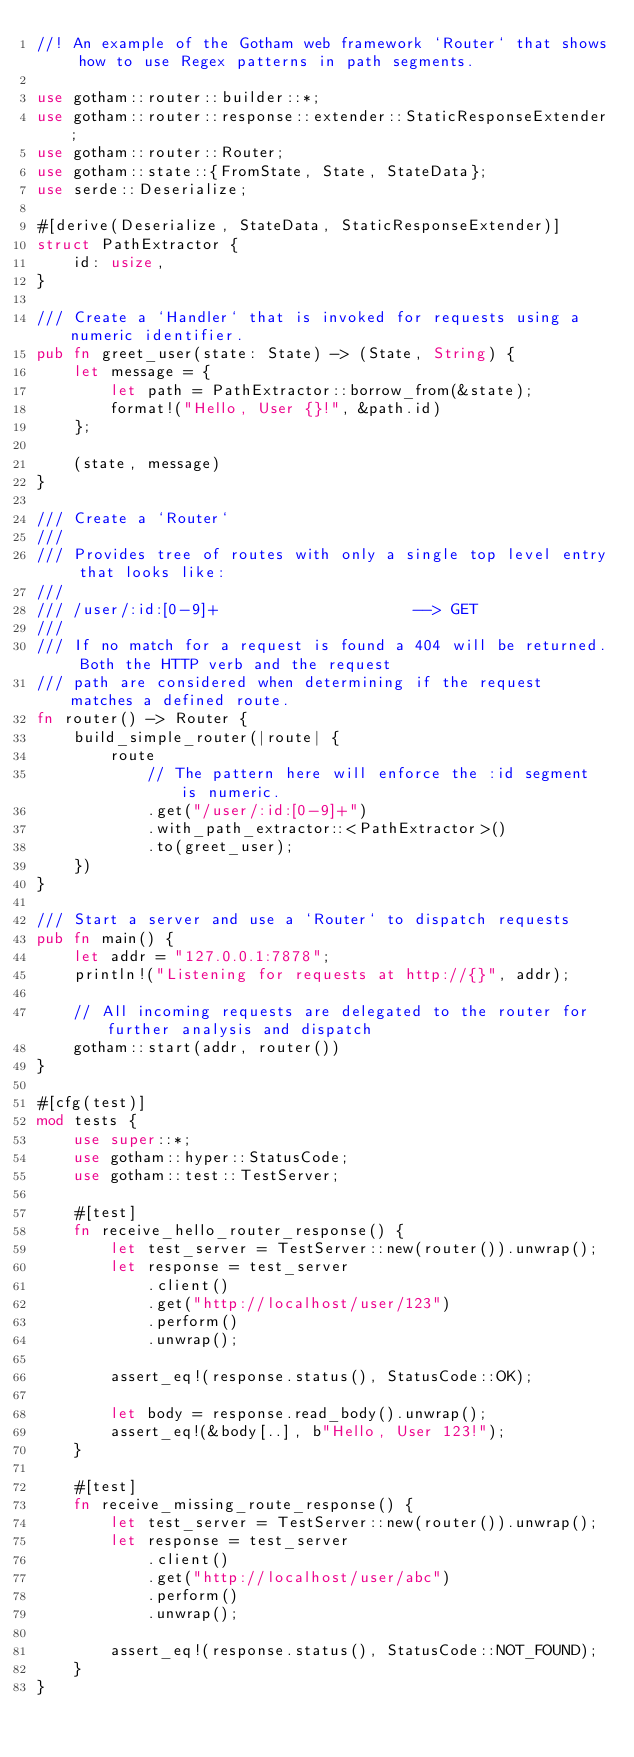<code> <loc_0><loc_0><loc_500><loc_500><_Rust_>//! An example of the Gotham web framework `Router` that shows how to use Regex patterns in path segments.

use gotham::router::builder::*;
use gotham::router::response::extender::StaticResponseExtender;
use gotham::router::Router;
use gotham::state::{FromState, State, StateData};
use serde::Deserialize;

#[derive(Deserialize, StateData, StaticResponseExtender)]
struct PathExtractor {
    id: usize,
}

/// Create a `Handler` that is invoked for requests using a numeric identifier.
pub fn greet_user(state: State) -> (State, String) {
    let message = {
        let path = PathExtractor::borrow_from(&state);
        format!("Hello, User {}!", &path.id)
    };

    (state, message)
}

/// Create a `Router`
///
/// Provides tree of routes with only a single top level entry that looks like:
///
/// /user/:id:[0-9]+                     --> GET
///
/// If no match for a request is found a 404 will be returned. Both the HTTP verb and the request
/// path are considered when determining if the request matches a defined route.
fn router() -> Router {
    build_simple_router(|route| {
        route
            // The pattern here will enforce the :id segment is numeric.
            .get("/user/:id:[0-9]+")
            .with_path_extractor::<PathExtractor>()
            .to(greet_user);
    })
}

/// Start a server and use a `Router` to dispatch requests
pub fn main() {
    let addr = "127.0.0.1:7878";
    println!("Listening for requests at http://{}", addr);

    // All incoming requests are delegated to the router for further analysis and dispatch
    gotham::start(addr, router())
}

#[cfg(test)]
mod tests {
    use super::*;
    use gotham::hyper::StatusCode;
    use gotham::test::TestServer;

    #[test]
    fn receive_hello_router_response() {
        let test_server = TestServer::new(router()).unwrap();
        let response = test_server
            .client()
            .get("http://localhost/user/123")
            .perform()
            .unwrap();

        assert_eq!(response.status(), StatusCode::OK);

        let body = response.read_body().unwrap();
        assert_eq!(&body[..], b"Hello, User 123!");
    }

    #[test]
    fn receive_missing_route_response() {
        let test_server = TestServer::new(router()).unwrap();
        let response = test_server
            .client()
            .get("http://localhost/user/abc")
            .perform()
            .unwrap();

        assert_eq!(response.status(), StatusCode::NOT_FOUND);
    }
}
</code> 